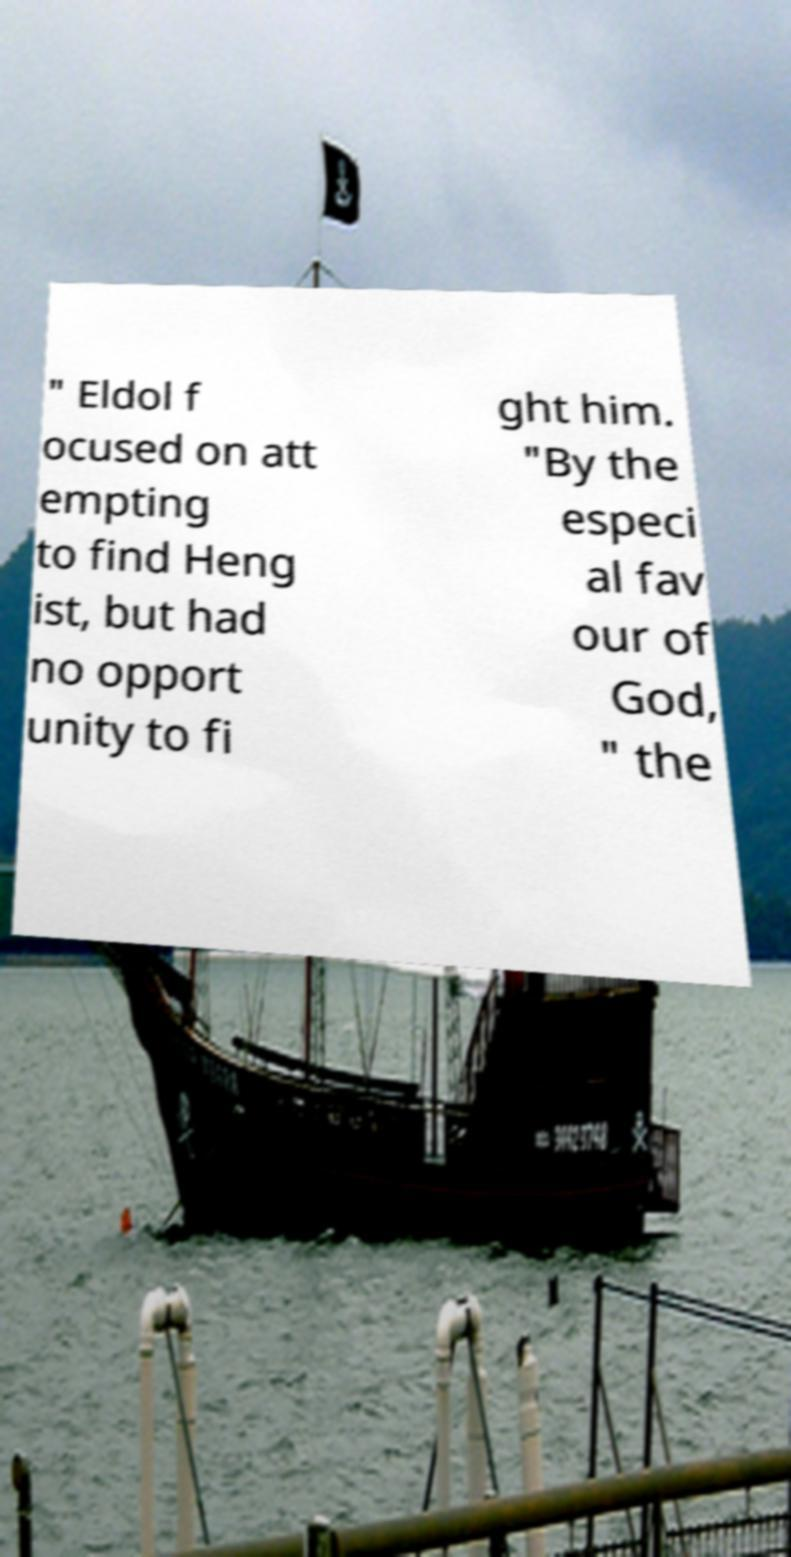Please identify and transcribe the text found in this image. " Eldol f ocused on att empting to find Heng ist, but had no opport unity to fi ght him. "By the especi al fav our of God, " the 